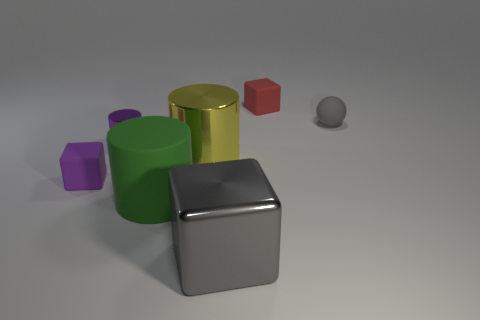The big matte object is what color?
Provide a succinct answer. Green. There is a gray cube; are there any large yellow things on the right side of it?
Offer a very short reply. No. Is the small ball the same color as the metal cube?
Your answer should be very brief. Yes. How many small things have the same color as the metallic cube?
Your answer should be compact. 1. How big is the matte object to the right of the block behind the tiny purple block?
Keep it short and to the point. Small. What is the shape of the small gray matte object?
Provide a succinct answer. Sphere. There is a block that is on the left side of the gray block; what is it made of?
Your answer should be very brief. Rubber. What is the color of the matte block that is on the right side of the big yellow metallic thing that is to the left of the small rubber cube behind the small ball?
Give a very brief answer. Red. The shiny thing that is the same size as the red block is what color?
Your answer should be compact. Purple. How many shiny things are large blocks or yellow cylinders?
Your answer should be very brief. 2. 